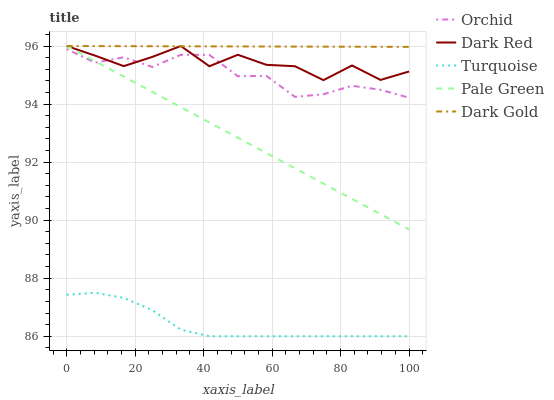Does Turquoise have the minimum area under the curve?
Answer yes or no. Yes. Does Dark Gold have the maximum area under the curve?
Answer yes or no. Yes. Does Pale Green have the minimum area under the curve?
Answer yes or no. No. Does Pale Green have the maximum area under the curve?
Answer yes or no. No. Is Dark Gold the smoothest?
Answer yes or no. Yes. Is Dark Red the roughest?
Answer yes or no. Yes. Is Turquoise the smoothest?
Answer yes or no. No. Is Turquoise the roughest?
Answer yes or no. No. Does Pale Green have the lowest value?
Answer yes or no. No. Does Turquoise have the highest value?
Answer yes or no. No. Is Orchid less than Dark Gold?
Answer yes or no. Yes. Is Orchid greater than Turquoise?
Answer yes or no. Yes. Does Orchid intersect Dark Gold?
Answer yes or no. No. 